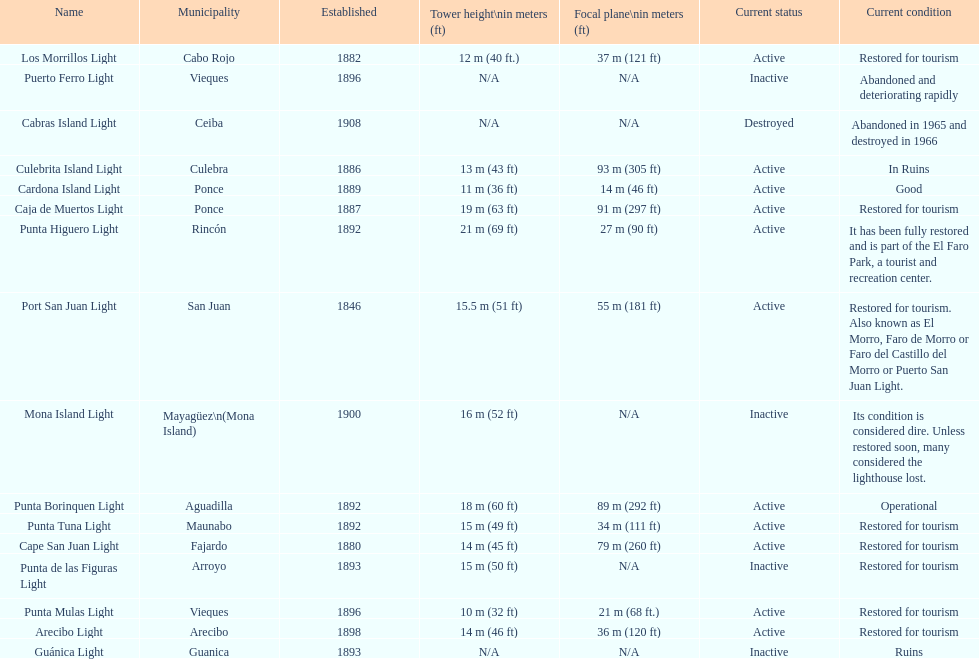What is the largest tower Punta Higuero Light. 